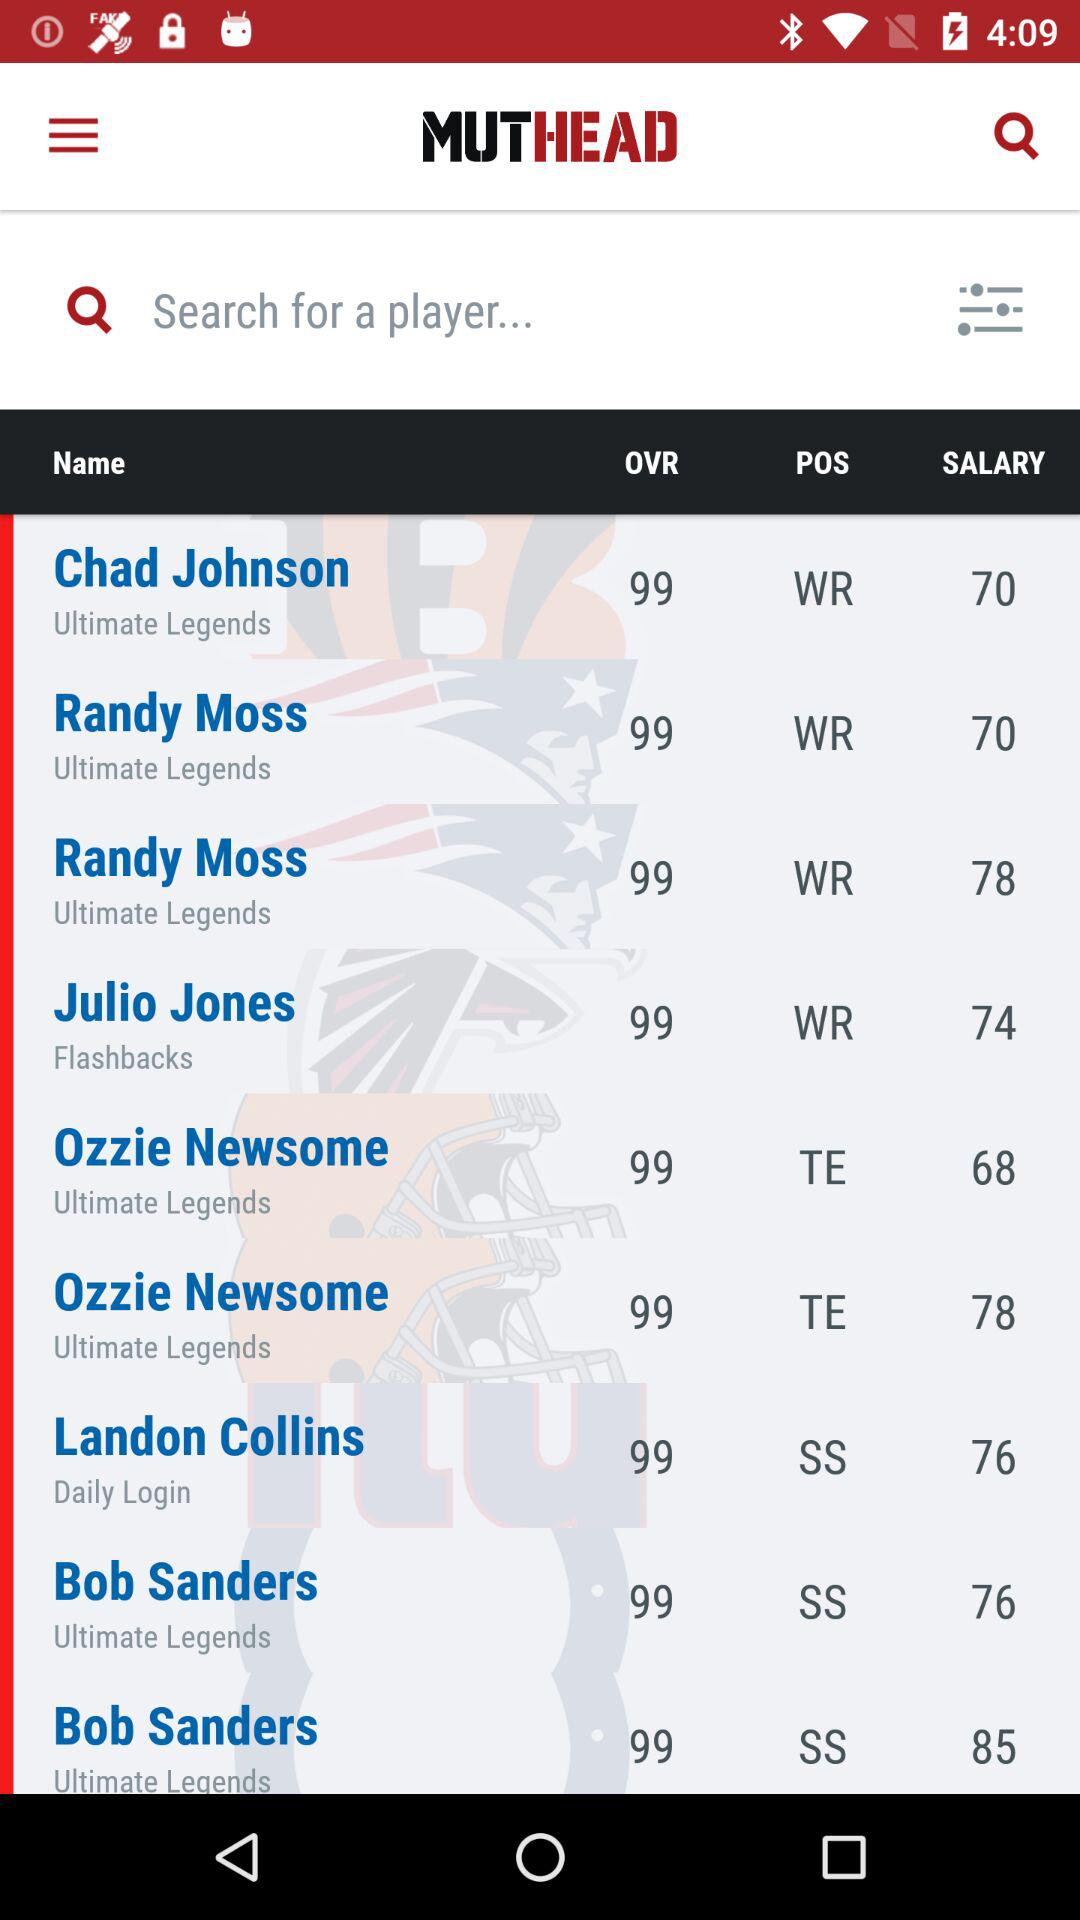At which position does Chad Johnson play? Chad Johnson plays at WR position. 